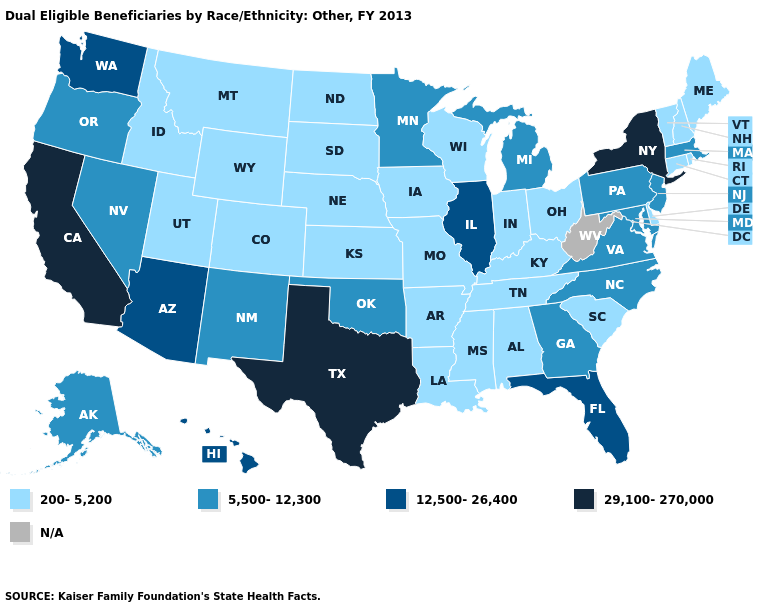What is the value of Nebraska?
Keep it brief. 200-5,200. Name the states that have a value in the range N/A?
Quick response, please. West Virginia. What is the value of Mississippi?
Keep it brief. 200-5,200. Which states hav the highest value in the MidWest?
Concise answer only. Illinois. Name the states that have a value in the range 200-5,200?
Be succinct. Alabama, Arkansas, Colorado, Connecticut, Delaware, Idaho, Indiana, Iowa, Kansas, Kentucky, Louisiana, Maine, Mississippi, Missouri, Montana, Nebraska, New Hampshire, North Dakota, Ohio, Rhode Island, South Carolina, South Dakota, Tennessee, Utah, Vermont, Wisconsin, Wyoming. What is the lowest value in the Northeast?
Answer briefly. 200-5,200. Name the states that have a value in the range N/A?
Answer briefly. West Virginia. Name the states that have a value in the range 200-5,200?
Write a very short answer. Alabama, Arkansas, Colorado, Connecticut, Delaware, Idaho, Indiana, Iowa, Kansas, Kentucky, Louisiana, Maine, Mississippi, Missouri, Montana, Nebraska, New Hampshire, North Dakota, Ohio, Rhode Island, South Carolina, South Dakota, Tennessee, Utah, Vermont, Wisconsin, Wyoming. Name the states that have a value in the range 12,500-26,400?
Keep it brief. Arizona, Florida, Hawaii, Illinois, Washington. Name the states that have a value in the range N/A?
Be succinct. West Virginia. Name the states that have a value in the range 200-5,200?
Be succinct. Alabama, Arkansas, Colorado, Connecticut, Delaware, Idaho, Indiana, Iowa, Kansas, Kentucky, Louisiana, Maine, Mississippi, Missouri, Montana, Nebraska, New Hampshire, North Dakota, Ohio, Rhode Island, South Carolina, South Dakota, Tennessee, Utah, Vermont, Wisconsin, Wyoming. Which states have the lowest value in the USA?
Answer briefly. Alabama, Arkansas, Colorado, Connecticut, Delaware, Idaho, Indiana, Iowa, Kansas, Kentucky, Louisiana, Maine, Mississippi, Missouri, Montana, Nebraska, New Hampshire, North Dakota, Ohio, Rhode Island, South Carolina, South Dakota, Tennessee, Utah, Vermont, Wisconsin, Wyoming. What is the value of Missouri?
Short answer required. 200-5,200. Does California have the highest value in the USA?
Short answer required. Yes. What is the highest value in the MidWest ?
Short answer required. 12,500-26,400. 